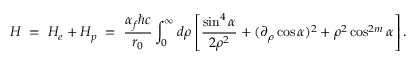Convert formula to latex. <formula><loc_0><loc_0><loc_500><loc_500>H \, = \, H _ { e } + H _ { p } \, = \, \frac { \alpha _ { f } \hbar { c } } { r _ { 0 } } \int _ { 0 } ^ { \infty } { d \rho } \left [ \frac { \sin ^ { 4 } \alpha } { 2 \rho ^ { 2 } } + ( \partial _ { \rho } \cos \alpha ) ^ { 2 } + \rho ^ { 2 } \cos ^ { 2 m } \alpha \right ] .</formula> 